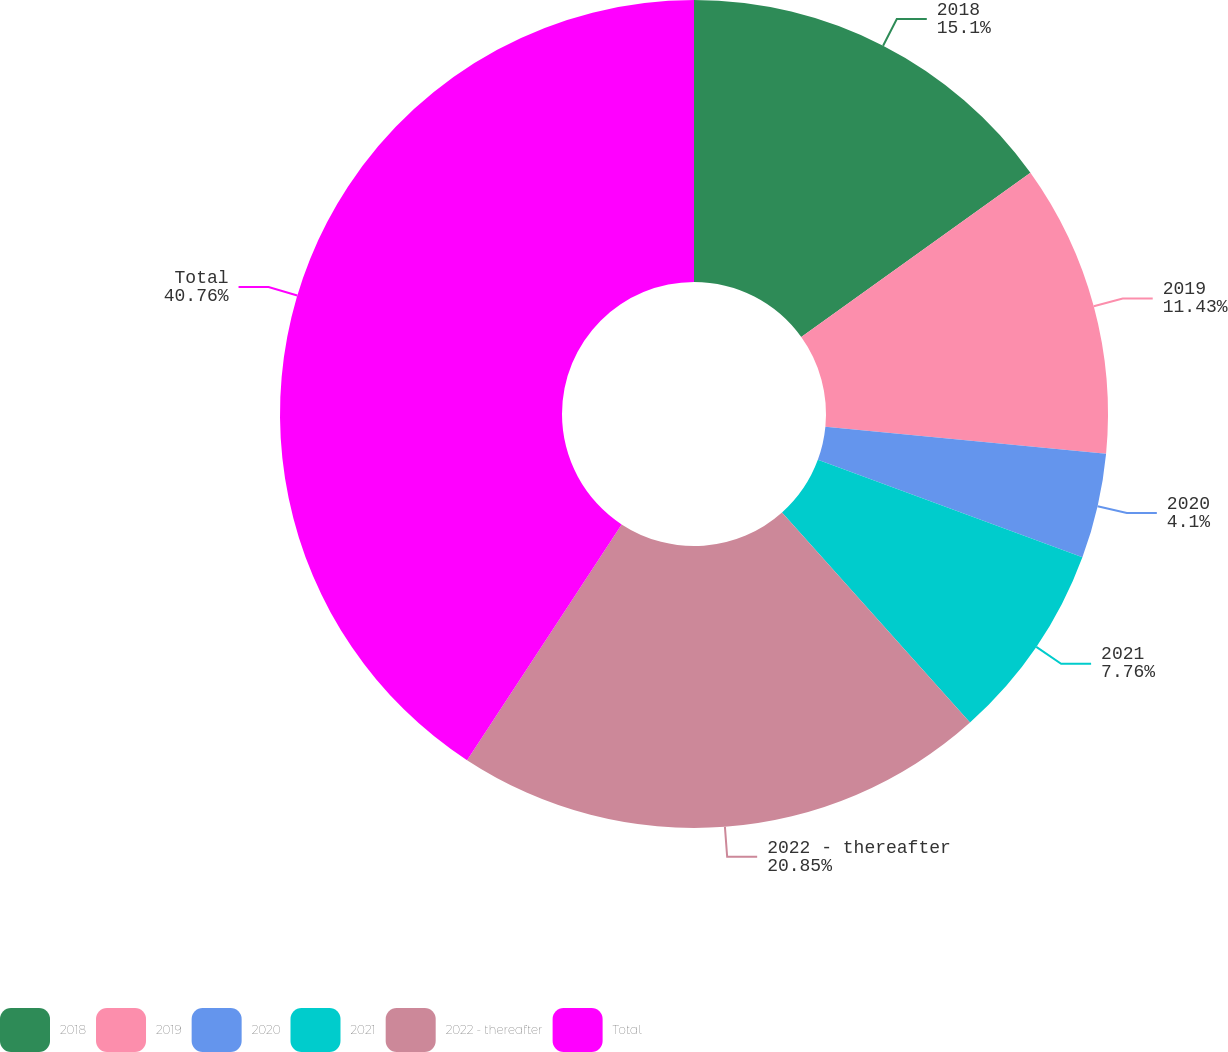<chart> <loc_0><loc_0><loc_500><loc_500><pie_chart><fcel>2018<fcel>2019<fcel>2020<fcel>2021<fcel>2022 - thereafter<fcel>Total<nl><fcel>15.1%<fcel>11.43%<fcel>4.1%<fcel>7.76%<fcel>20.85%<fcel>40.77%<nl></chart> 